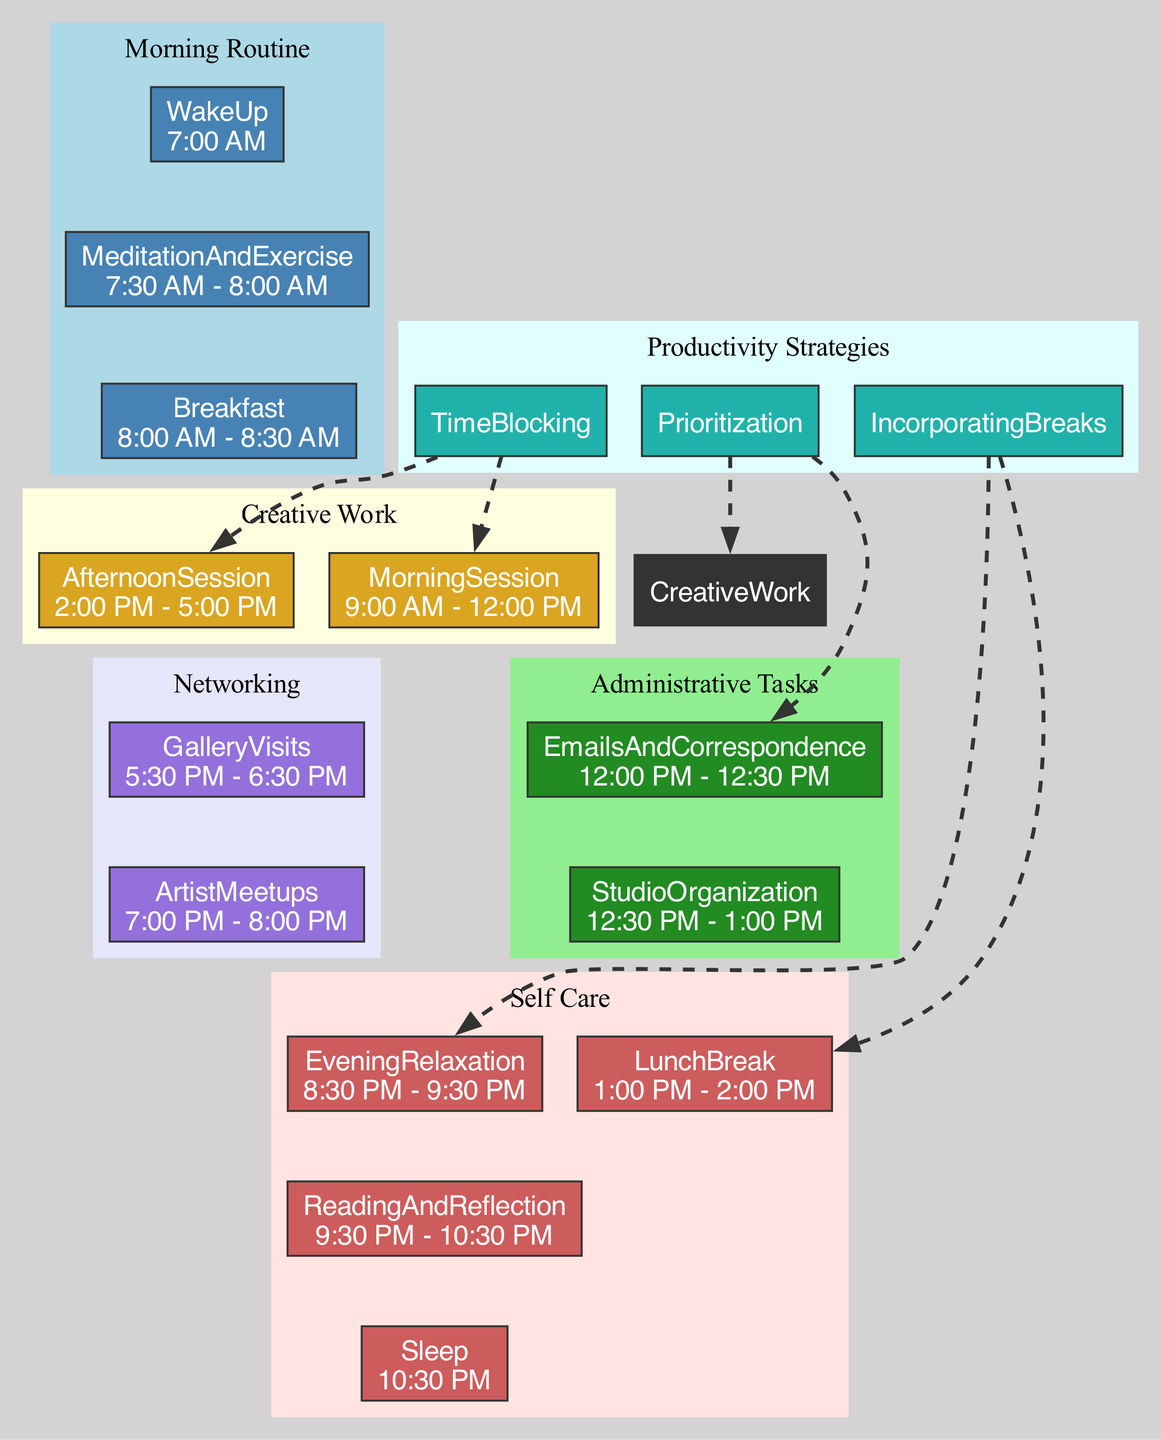what time is the morning session for creative work? The diagram indicates that the morning session for creative work takes place from 9:00 AM to 12:00 PM. This information is found in the 'Creative Work' section under 'MorningSession'.
Answer: 9:00 AM - 12:00 PM what activities are included in self-care? The 'Self Care' section lists various activities to maintain well-being. These activities are LunchBreak, EveningRelaxation, ReadingAndReflection, and Sleep as specified in the diagram.
Answer: LunchBreak, EveningRelaxation, ReadingAndReflection, Sleep what is the duration of the administrative tasks? The administrative tasks consist of EmailsAndCorrespondence from 12:00 PM to 12:30 PM (30 minutes) and StudioOrganization from 12:30 PM to 1:00 PM (30 minutes). When combined, the total duration is 1 hour.
Answer: 1 hour how are breaks incorporated into the daily routine? The diagram shows breaks incorporated through designated periods such as LunchBreak and EveningRelaxation listed in the 'Self Care' section. These breaks help maintain productivity by allowing time for relaxation.
Answer: LunchBreak, EveningRelaxation which productivity strategy involves task prioritization? The diagram specifies that the 'Prioritization' strategy is part of the productivity strategies. It emphasizes prioritizing tasks like EmailsAndCorrespondence and CreativeWork to enhance efficiency.
Answer: Prioritization how many networking activities are scheduled in the evening? The 'Networking' section indicates two activities: GalleryVisits from 5:30 PM to 6:30 PM and ArtistMeetups from 7:00 PM to 8:00 PM. Therefore, there are two networking activities planned in the evening.
Answer: 2 what is the total number of tasks listed in the creative work section? In the 'Creative Work' section, there are two tasks: MorningSession and AfternoonSession. Hence, counting these gives a total of two tasks under creative work.
Answer: 2 how does the daily routine incorporate time blocking? The 'Productivity Strategies' section shows that the 'TimeBlocking' strategy involves dedicated periods for MorningSession and AfternoonSession, which organizes creative work effectively. This means specific times are allocated for focused effort.
Answer: MorningSession, AfternoonSession what time does the evening relaxation start? The diagram clearly indicates that EveningRelaxation starts at 8:30 PM, which is the designated time for unwinding after a day's work.
Answer: 8:30 PM 